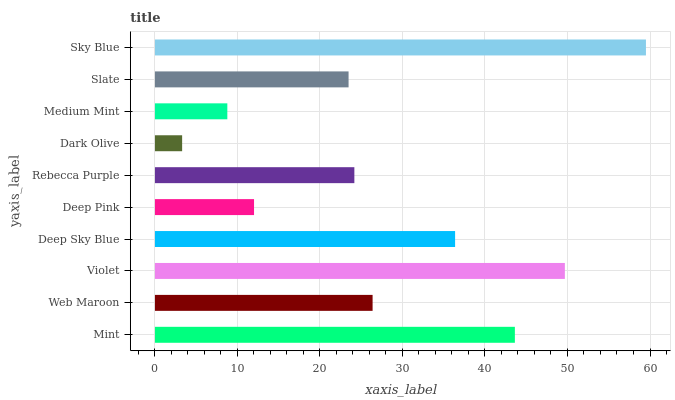Is Dark Olive the minimum?
Answer yes or no. Yes. Is Sky Blue the maximum?
Answer yes or no. Yes. Is Web Maroon the minimum?
Answer yes or no. No. Is Web Maroon the maximum?
Answer yes or no. No. Is Mint greater than Web Maroon?
Answer yes or no. Yes. Is Web Maroon less than Mint?
Answer yes or no. Yes. Is Web Maroon greater than Mint?
Answer yes or no. No. Is Mint less than Web Maroon?
Answer yes or no. No. Is Web Maroon the high median?
Answer yes or no. Yes. Is Rebecca Purple the low median?
Answer yes or no. Yes. Is Mint the high median?
Answer yes or no. No. Is Dark Olive the low median?
Answer yes or no. No. 